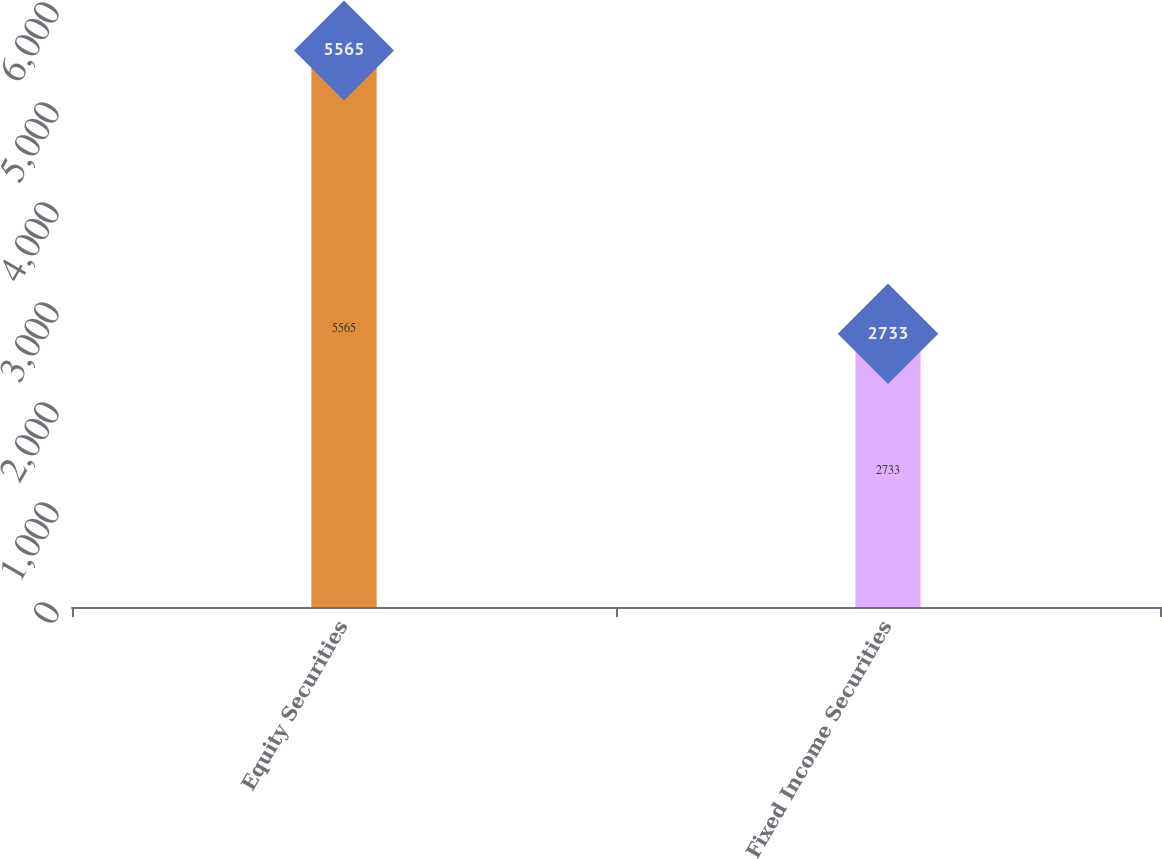Convert chart to OTSL. <chart><loc_0><loc_0><loc_500><loc_500><bar_chart><fcel>Equity Securities<fcel>Fixed Income Securities<nl><fcel>5565<fcel>2733<nl></chart> 